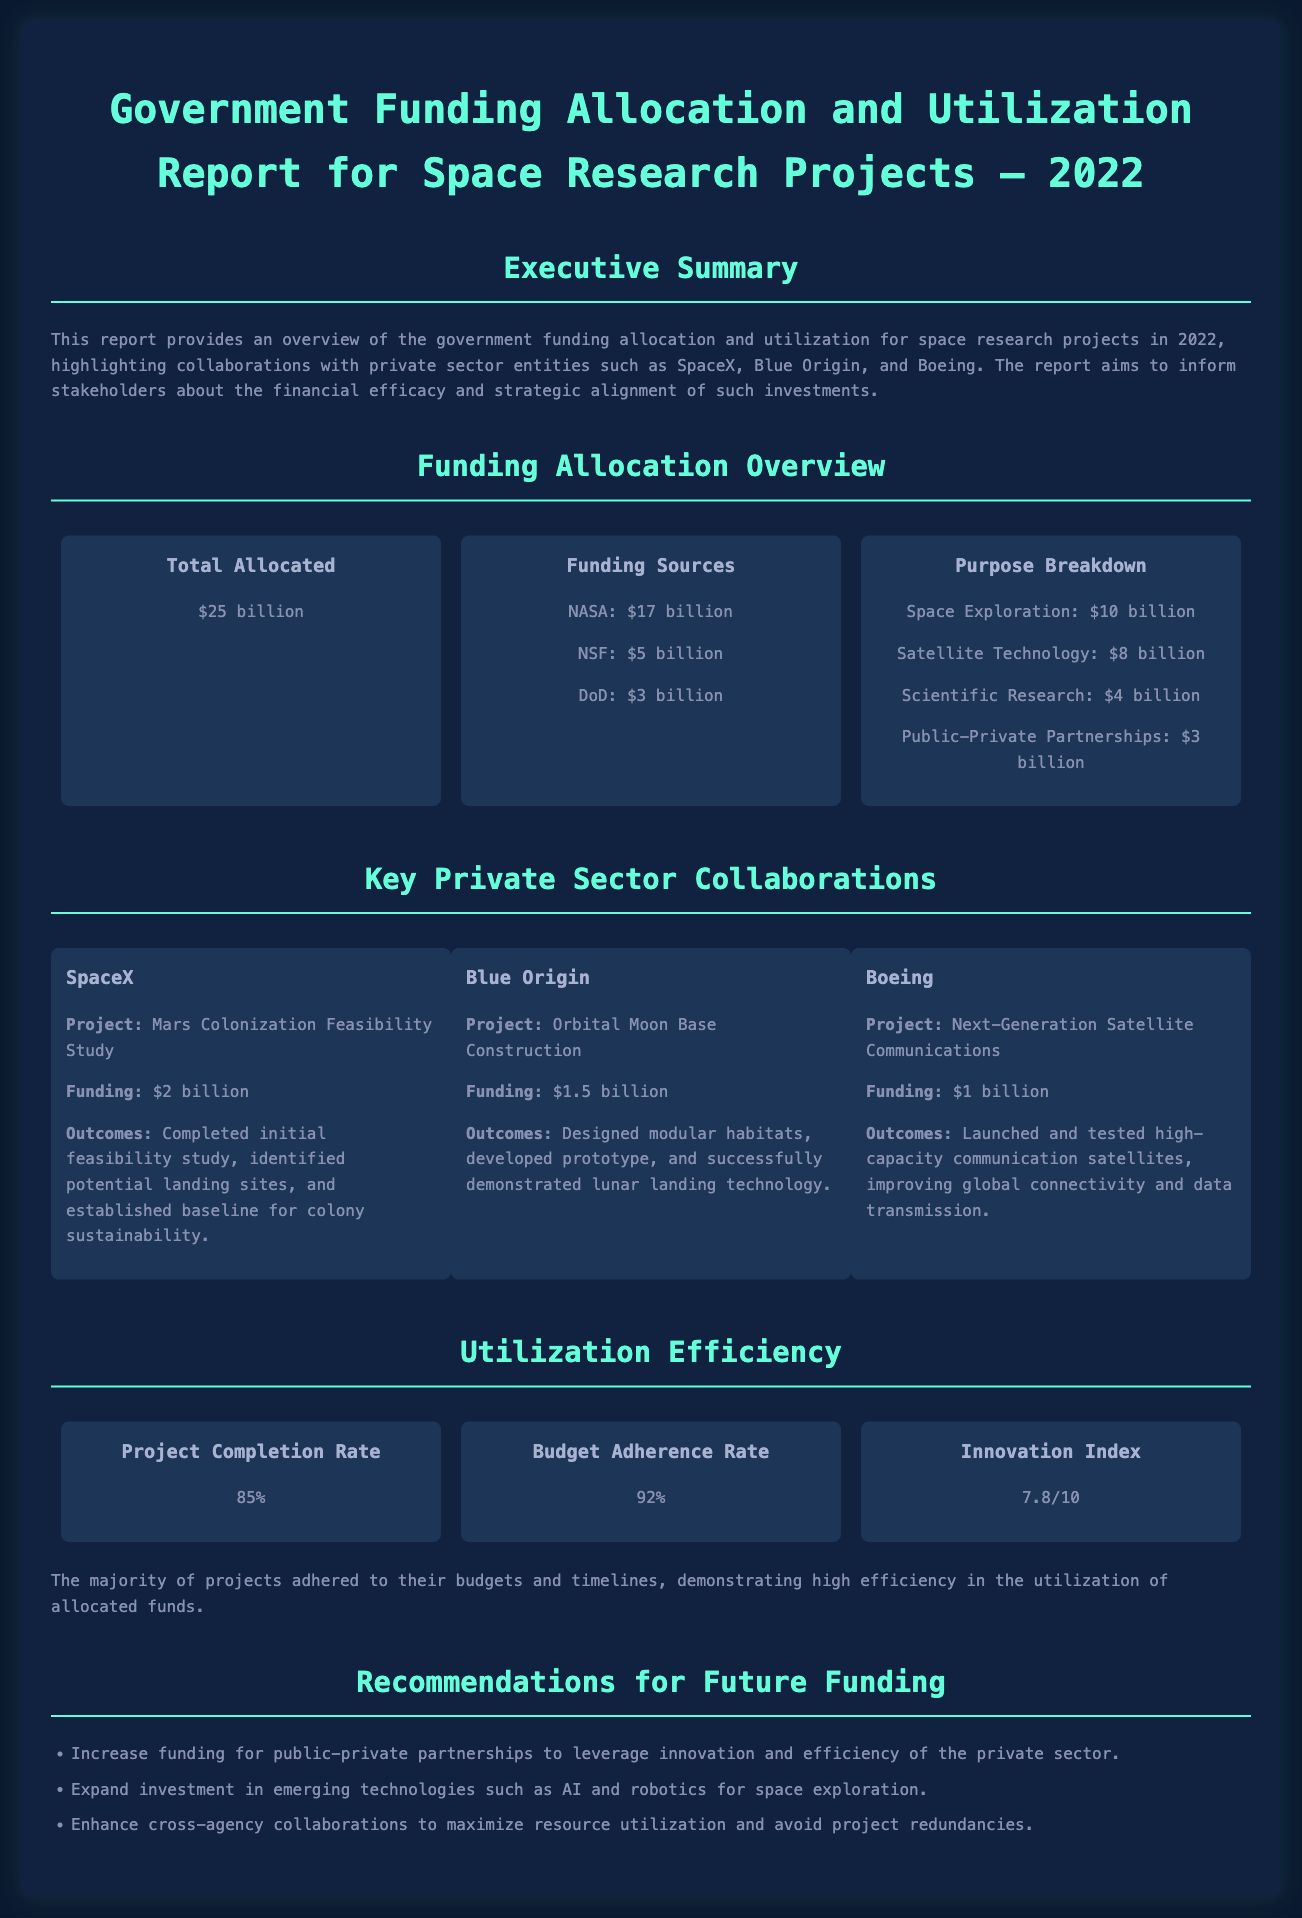What is the total allocated funding for space research projects in 2022? The total allocated funding is mentioned explicitly in the funding overview section of the document.
Answer: $25 billion Which agency contributed the most funding? The funding sources section identifies NASA as the largest contributor.
Answer: NASA What is the funding amount for the Mars Colonization Feasibility Study? The document specifies the funding amount allocated to SpaceX for this project.
Answer: $2 billion What was the project completion rate? The utilization efficiency section provides the project completion rate as part of efficiency metrics.
Answer: 85% What is the Innovation Index score? The document reveals the Innovation Index as a measure of project creativity.
Answer: 7.8/10 Which private sector partner worked on the Orbital Moon Base Construction? The collaborations section specifically names Blue Origin as the partner for this project.
Answer: Blue Origin What recommendation emphasizes the need for public-private partnerships? The recommendations section includes mentions of increasing funding for these partnerships.
Answer: Increase funding for public-private partnerships How much funding was allocated for Scientific Research? The purpose breakdown section details the funding amount specifically for Scientific Research.
Answer: $4 billion What was the budget adherence rate for projects? The utilization efficiency section mentions the budget adherence rate indicative of financial management.
Answer: 92% 